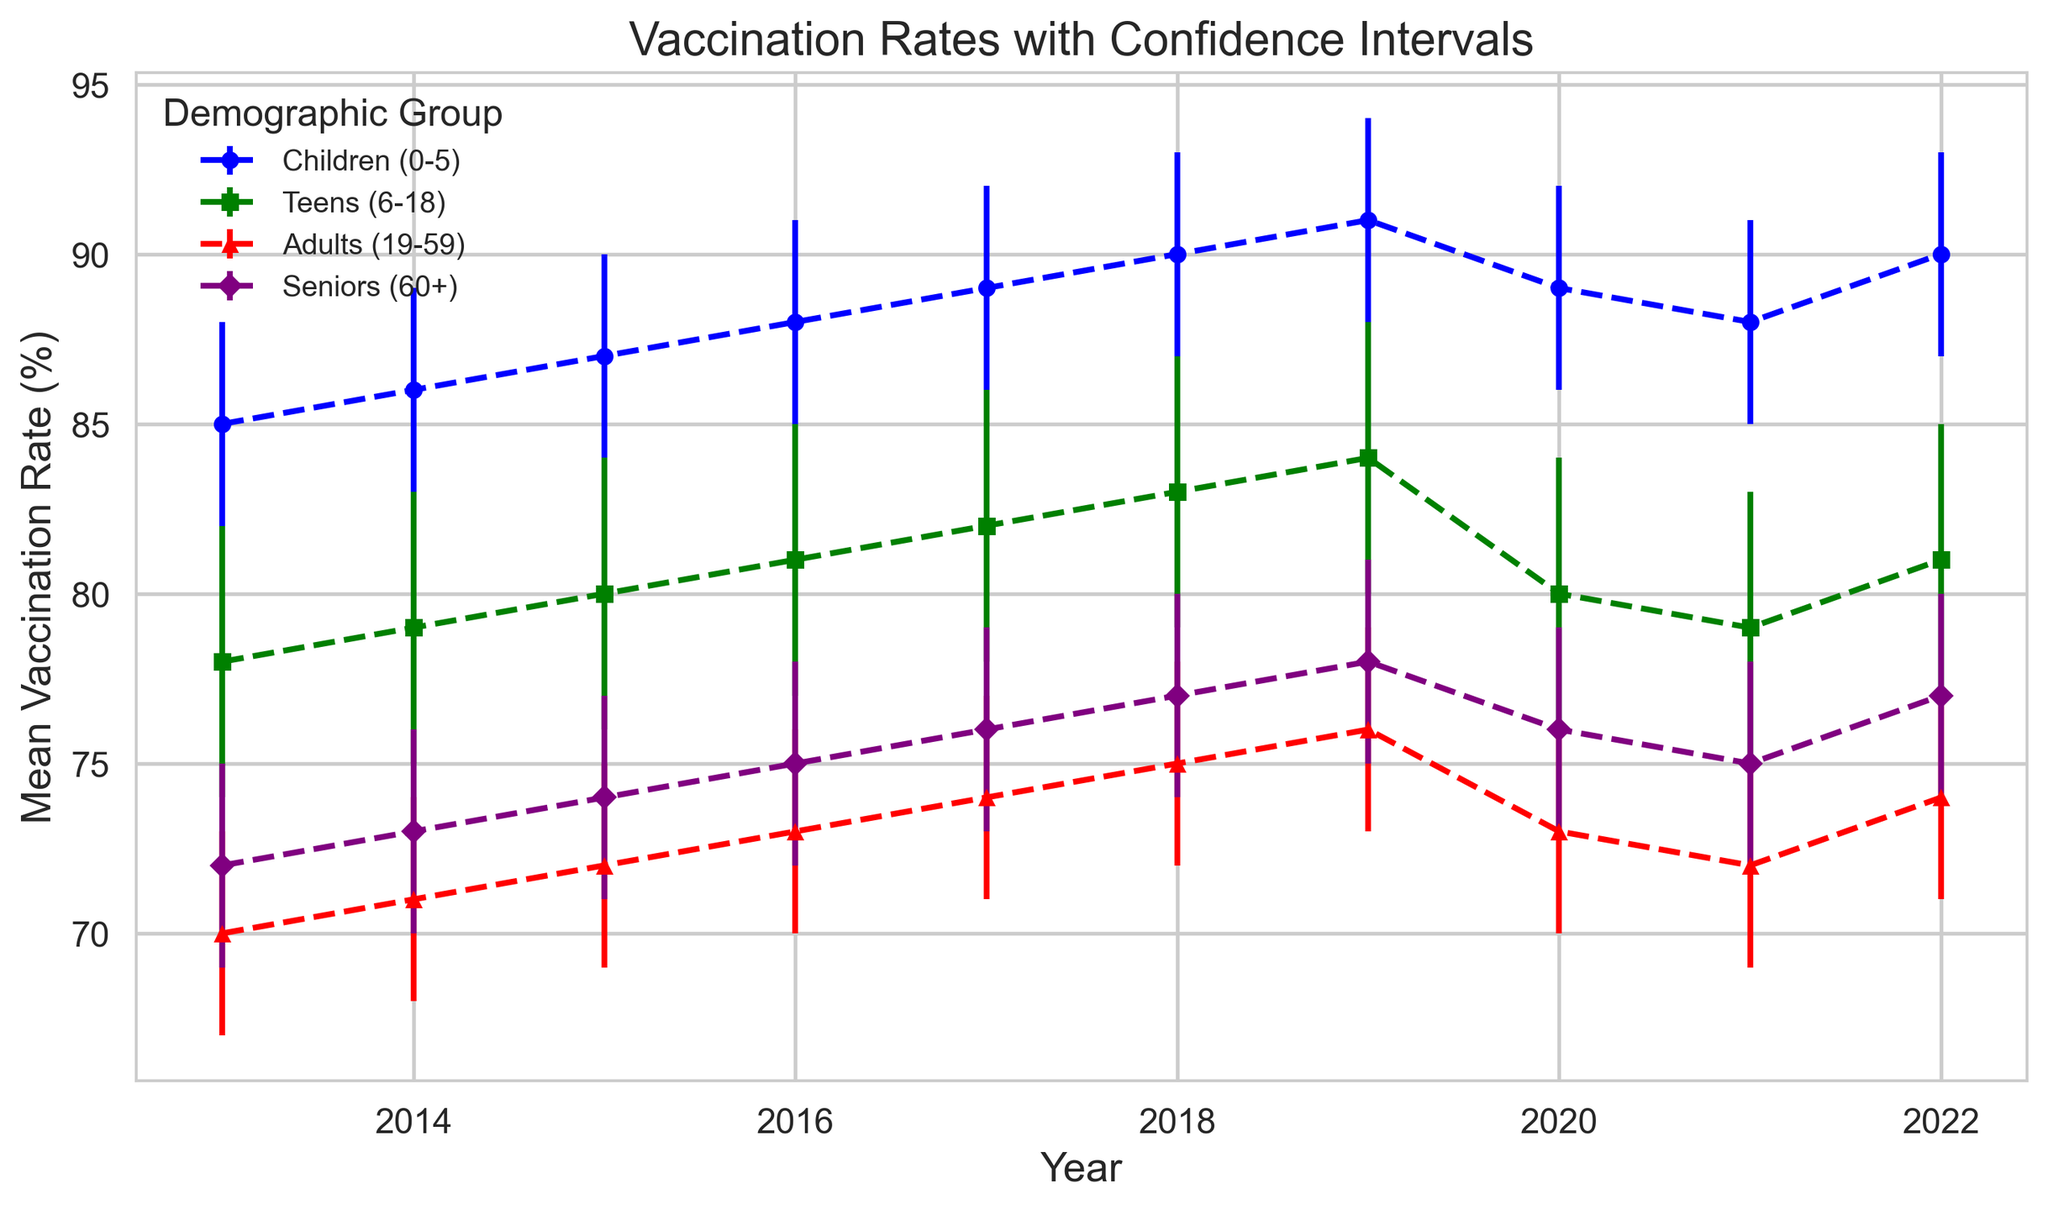Which demographic group had the highest mean vaccination rate in 2022? The figure shows that in 2022, the "Children (0-5)" group had a mean vaccination rate of 90%, which is the highest among all groups.
Answer: Children (0-5) How did the mean vaccination rate of "Seniors (60+)" change from 2013 to 2019? The mean vaccination rate in 2013 was 72%, and it increased to 78% by 2019. Therefore, the change is 78% - 72% = 6%.
Answer: Increased by 6% Which demographic group showed the smallest change in mean vaccination rate over the decade? By analyzing the differences between the 2013 and 2022 mean vaccination rates for each group: 
- Children (0-5): 90% - 85% = 5%
- Teens (6-18): 81% - 78% = 3%
- Adults (19-59): 74% - 70% = 4%
- Seniors (60+): 77% - 72% = 5%
The "Teens (6-18)" group showed the smallest change, which is 3%.
Answer: Teens (6-18) Between which two consecutive years did the mean vaccination rate for "Teens (6-18)" exhibit the largest decrease? From the figure, the relevant mean vaccination rates are:
- 2019: 84%
- 2020: 80%
- The decrease from 2019 to 2020 is 84% - 80% = 4%.
This is the largest decrease seen for this demographic over two consecutive years.
Answer: 2019 to 2020 What is the average mean vaccination rate for "Adults (19-59)" over the last decade? Summing up the mean rates from 2013 to 2022: 70 + 71 + 72 + 73 + 74 + 75 + 76 + 73 + 72 + 74 = 730. The average is then 730/10 = 73%.
Answer: 73% Which demographic group had the largest confidence interval (CI) range in 2015? Examining the CI values:
- Children (0-5): 90 - 84 = 6
- Teens (6-18): 84 - 76 = 8
- Adults (19-59): 75 - 69 = 6
- Seniors (60+): 77 - 71 = 6
The "Teens (6-18)" group had the largest CI range of 8% in 2015.
Answer: Teens (6-18) In which year did "Children (0-5)" have their highest mean vaccination rate? According to the figure, the highest rate for "Children (0-5)" is 91% in 2019.
Answer: 2019 For "Adults (19-59)", which year had the narrowest confidence interval? Analyzing the width of the intervals (Upper CI - Lower CI):
- 2013: 73 - 67 = 6
- 2014: 74 - 68 = 6
- 2015: 75 - 69 = 6
- 2016: 76 - 70 = 6
- 2017: 77 - 71 = 6
- 2018: 78 - 72 = 6
- 2019: 79 - 73 = 6
- 2020: 76 - 70 = 6
- 2021: 75 - 69 = 6
- 2022: 77 - 71 = 6
The CI range for "Adults (19-59)" is consistently 6% every year, indicating there is no narrowest interval—it is equal each year.
Answer: Consistently 6% every year 